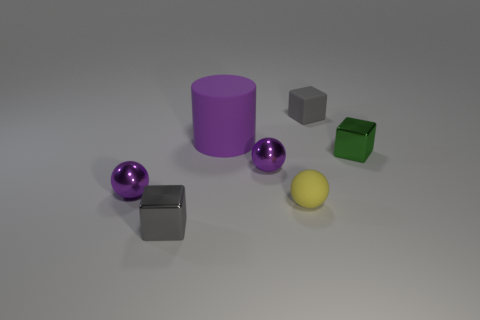Do the big cylinder and the tiny rubber sphere have the same color?
Keep it short and to the point. No. Is there anything else that has the same shape as the small yellow thing?
Your answer should be compact. Yes. There is another cube that is the same color as the matte block; what is its material?
Give a very brief answer. Metal. Is the number of yellow rubber things behind the matte sphere the same as the number of blue objects?
Ensure brevity in your answer.  Yes. There is a yellow object; are there any tiny metallic things to the left of it?
Offer a terse response. Yes. Does the gray rubber thing have the same shape as the small gray thing that is in front of the tiny matte cube?
Offer a terse response. Yes. What is the color of the block that is the same material as the tiny yellow sphere?
Your answer should be very brief. Gray. What color is the big matte thing?
Make the answer very short. Purple. Is the material of the cylinder the same as the tiny gray object that is left of the tiny yellow sphere?
Offer a very short reply. No. What number of objects are both right of the rubber cube and left of the large object?
Provide a short and direct response. 0. 